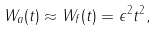<formula> <loc_0><loc_0><loc_500><loc_500>W _ { a } ( t ) \approx W _ { f } ( t ) = \epsilon ^ { 2 } t ^ { 2 } ,</formula> 